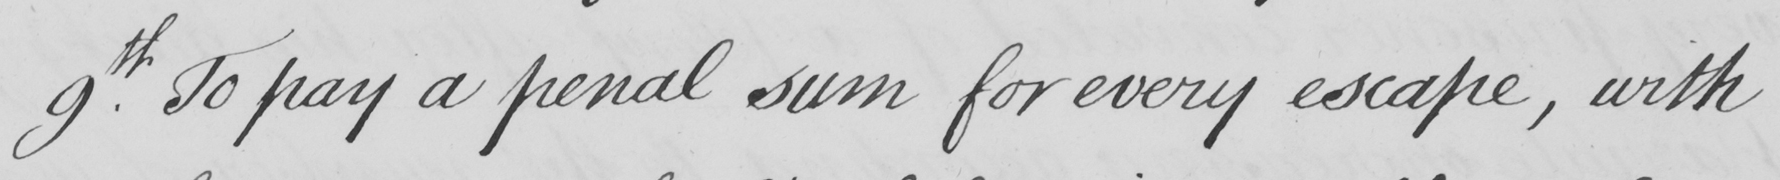Transcribe the text shown in this historical manuscript line. 9.th To pay a penal sum for every escape , with 